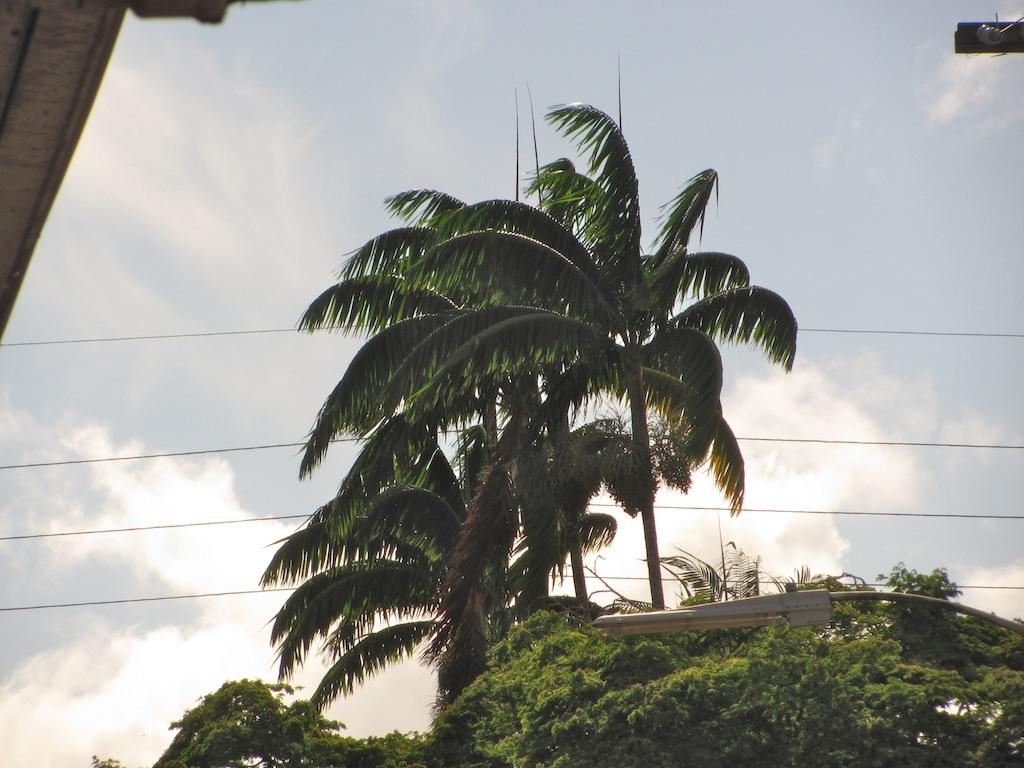What is the primary feature of the image? The primary feature of the image is the presence of many trees. Are there any other objects or structures visible among the trees? Yes, there are wires visible between the trees. What can be seen on the right side of the image? There is a street light on the right side of the image. How many bricks are used to build the squirrel's home in the image? There is no squirrel or its home present in the image, so it is not possible to determine the number of bricks used. 